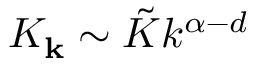Convert formula to latex. <formula><loc_0><loc_0><loc_500><loc_500>K _ { k } \sim \tilde { K } k ^ { \alpha - d }</formula> 